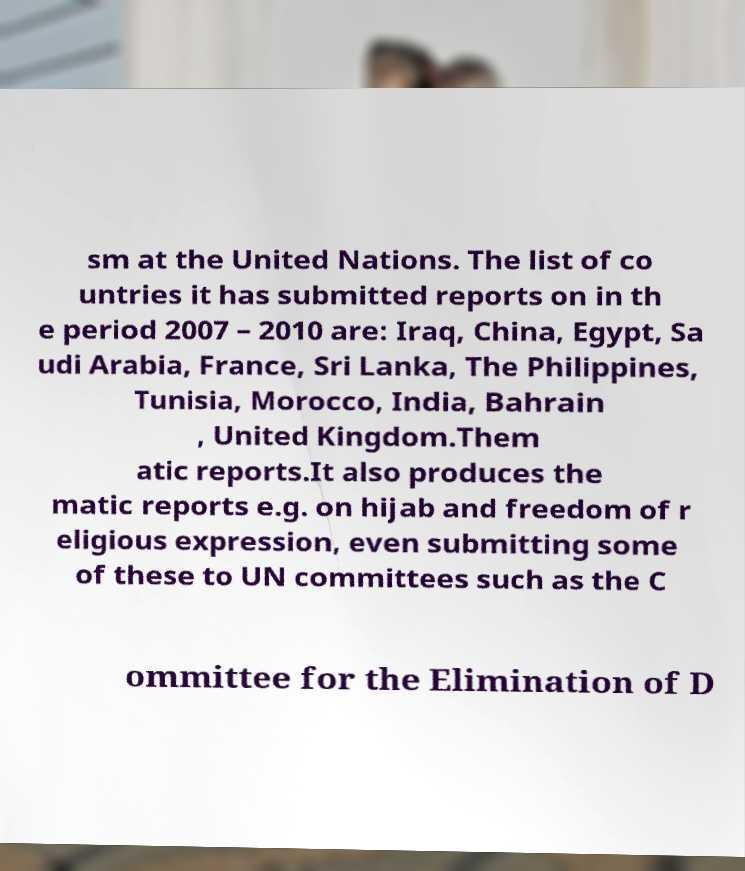For documentation purposes, I need the text within this image transcribed. Could you provide that? sm at the United Nations. The list of co untries it has submitted reports on in th e period 2007 – 2010 are: Iraq, China, Egypt, Sa udi Arabia, France, Sri Lanka, The Philippines, Tunisia, Morocco, India, Bahrain , United Kingdom.Them atic reports.It also produces the matic reports e.g. on hijab and freedom of r eligious expression, even submitting some of these to UN committees such as the C ommittee for the Elimination of D 